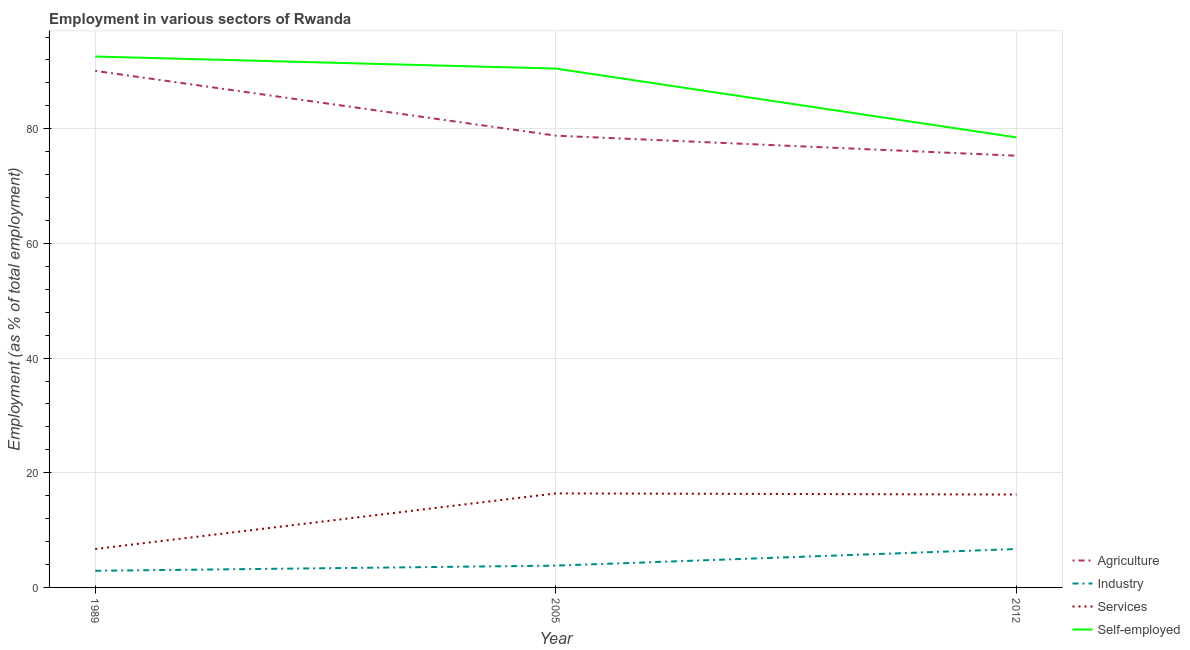Does the line corresponding to percentage of self employed workers intersect with the line corresponding to percentage of workers in agriculture?
Your answer should be compact. No. Is the number of lines equal to the number of legend labels?
Make the answer very short. Yes. What is the percentage of self employed workers in 2012?
Provide a succinct answer. 78.5. Across all years, what is the maximum percentage of self employed workers?
Provide a short and direct response. 92.6. Across all years, what is the minimum percentage of workers in agriculture?
Give a very brief answer. 75.3. In which year was the percentage of workers in agriculture minimum?
Keep it short and to the point. 2012. What is the total percentage of workers in services in the graph?
Offer a very short reply. 39.3. What is the difference between the percentage of self employed workers in 1989 and that in 2005?
Offer a very short reply. 2.1. What is the difference between the percentage of workers in services in 2012 and the percentage of self employed workers in 2005?
Offer a terse response. -74.3. What is the average percentage of workers in agriculture per year?
Give a very brief answer. 81.4. In the year 2005, what is the difference between the percentage of workers in agriculture and percentage of workers in services?
Ensure brevity in your answer.  62.4. In how many years, is the percentage of self employed workers greater than 56 %?
Keep it short and to the point. 3. What is the ratio of the percentage of workers in industry in 2005 to that in 2012?
Keep it short and to the point. 0.57. Is the percentage of workers in agriculture in 1989 less than that in 2005?
Your response must be concise. No. What is the difference between the highest and the second highest percentage of workers in services?
Ensure brevity in your answer.  0.2. What is the difference between the highest and the lowest percentage of workers in industry?
Keep it short and to the point. 3.8. In how many years, is the percentage of workers in services greater than the average percentage of workers in services taken over all years?
Your answer should be compact. 2. Is it the case that in every year, the sum of the percentage of workers in services and percentage of workers in industry is greater than the sum of percentage of self employed workers and percentage of workers in agriculture?
Give a very brief answer. No. Is the percentage of workers in industry strictly less than the percentage of self employed workers over the years?
Provide a short and direct response. Yes. How many lines are there?
Offer a terse response. 4. Are the values on the major ticks of Y-axis written in scientific E-notation?
Make the answer very short. No. Does the graph contain any zero values?
Ensure brevity in your answer.  No. How many legend labels are there?
Offer a very short reply. 4. What is the title of the graph?
Provide a short and direct response. Employment in various sectors of Rwanda. What is the label or title of the X-axis?
Offer a very short reply. Year. What is the label or title of the Y-axis?
Provide a succinct answer. Employment (as % of total employment). What is the Employment (as % of total employment) of Agriculture in 1989?
Offer a very short reply. 90.1. What is the Employment (as % of total employment) of Industry in 1989?
Ensure brevity in your answer.  2.9. What is the Employment (as % of total employment) in Services in 1989?
Keep it short and to the point. 6.7. What is the Employment (as % of total employment) in Self-employed in 1989?
Your response must be concise. 92.6. What is the Employment (as % of total employment) of Agriculture in 2005?
Offer a very short reply. 78.8. What is the Employment (as % of total employment) in Industry in 2005?
Ensure brevity in your answer.  3.8. What is the Employment (as % of total employment) in Services in 2005?
Provide a short and direct response. 16.4. What is the Employment (as % of total employment) in Self-employed in 2005?
Your answer should be very brief. 90.5. What is the Employment (as % of total employment) of Agriculture in 2012?
Your response must be concise. 75.3. What is the Employment (as % of total employment) in Industry in 2012?
Offer a terse response. 6.7. What is the Employment (as % of total employment) in Services in 2012?
Offer a very short reply. 16.2. What is the Employment (as % of total employment) of Self-employed in 2012?
Provide a short and direct response. 78.5. Across all years, what is the maximum Employment (as % of total employment) in Agriculture?
Keep it short and to the point. 90.1. Across all years, what is the maximum Employment (as % of total employment) in Industry?
Your response must be concise. 6.7. Across all years, what is the maximum Employment (as % of total employment) in Services?
Offer a very short reply. 16.4. Across all years, what is the maximum Employment (as % of total employment) in Self-employed?
Make the answer very short. 92.6. Across all years, what is the minimum Employment (as % of total employment) in Agriculture?
Keep it short and to the point. 75.3. Across all years, what is the minimum Employment (as % of total employment) of Industry?
Ensure brevity in your answer.  2.9. Across all years, what is the minimum Employment (as % of total employment) in Services?
Keep it short and to the point. 6.7. Across all years, what is the minimum Employment (as % of total employment) of Self-employed?
Your response must be concise. 78.5. What is the total Employment (as % of total employment) of Agriculture in the graph?
Your response must be concise. 244.2. What is the total Employment (as % of total employment) in Services in the graph?
Your response must be concise. 39.3. What is the total Employment (as % of total employment) in Self-employed in the graph?
Your answer should be compact. 261.6. What is the difference between the Employment (as % of total employment) in Agriculture in 1989 and that in 2005?
Offer a terse response. 11.3. What is the difference between the Employment (as % of total employment) in Industry in 1989 and that in 2005?
Provide a succinct answer. -0.9. What is the difference between the Employment (as % of total employment) in Services in 1989 and that in 2005?
Give a very brief answer. -9.7. What is the difference between the Employment (as % of total employment) of Self-employed in 1989 and that in 2012?
Offer a terse response. 14.1. What is the difference between the Employment (as % of total employment) in Agriculture in 2005 and that in 2012?
Provide a succinct answer. 3.5. What is the difference between the Employment (as % of total employment) of Industry in 2005 and that in 2012?
Your response must be concise. -2.9. What is the difference between the Employment (as % of total employment) of Services in 2005 and that in 2012?
Provide a succinct answer. 0.2. What is the difference between the Employment (as % of total employment) in Agriculture in 1989 and the Employment (as % of total employment) in Industry in 2005?
Give a very brief answer. 86.3. What is the difference between the Employment (as % of total employment) of Agriculture in 1989 and the Employment (as % of total employment) of Services in 2005?
Keep it short and to the point. 73.7. What is the difference between the Employment (as % of total employment) of Agriculture in 1989 and the Employment (as % of total employment) of Self-employed in 2005?
Keep it short and to the point. -0.4. What is the difference between the Employment (as % of total employment) of Industry in 1989 and the Employment (as % of total employment) of Self-employed in 2005?
Provide a short and direct response. -87.6. What is the difference between the Employment (as % of total employment) of Services in 1989 and the Employment (as % of total employment) of Self-employed in 2005?
Provide a succinct answer. -83.8. What is the difference between the Employment (as % of total employment) of Agriculture in 1989 and the Employment (as % of total employment) of Industry in 2012?
Provide a succinct answer. 83.4. What is the difference between the Employment (as % of total employment) in Agriculture in 1989 and the Employment (as % of total employment) in Services in 2012?
Provide a succinct answer. 73.9. What is the difference between the Employment (as % of total employment) in Industry in 1989 and the Employment (as % of total employment) in Services in 2012?
Provide a short and direct response. -13.3. What is the difference between the Employment (as % of total employment) in Industry in 1989 and the Employment (as % of total employment) in Self-employed in 2012?
Keep it short and to the point. -75.6. What is the difference between the Employment (as % of total employment) of Services in 1989 and the Employment (as % of total employment) of Self-employed in 2012?
Your response must be concise. -71.8. What is the difference between the Employment (as % of total employment) of Agriculture in 2005 and the Employment (as % of total employment) of Industry in 2012?
Your answer should be very brief. 72.1. What is the difference between the Employment (as % of total employment) in Agriculture in 2005 and the Employment (as % of total employment) in Services in 2012?
Ensure brevity in your answer.  62.6. What is the difference between the Employment (as % of total employment) of Agriculture in 2005 and the Employment (as % of total employment) of Self-employed in 2012?
Ensure brevity in your answer.  0.3. What is the difference between the Employment (as % of total employment) in Industry in 2005 and the Employment (as % of total employment) in Self-employed in 2012?
Offer a terse response. -74.7. What is the difference between the Employment (as % of total employment) in Services in 2005 and the Employment (as % of total employment) in Self-employed in 2012?
Your answer should be very brief. -62.1. What is the average Employment (as % of total employment) of Agriculture per year?
Ensure brevity in your answer.  81.4. What is the average Employment (as % of total employment) of Industry per year?
Offer a terse response. 4.47. What is the average Employment (as % of total employment) in Self-employed per year?
Keep it short and to the point. 87.2. In the year 1989, what is the difference between the Employment (as % of total employment) in Agriculture and Employment (as % of total employment) in Industry?
Provide a succinct answer. 87.2. In the year 1989, what is the difference between the Employment (as % of total employment) in Agriculture and Employment (as % of total employment) in Services?
Give a very brief answer. 83.4. In the year 1989, what is the difference between the Employment (as % of total employment) of Industry and Employment (as % of total employment) of Self-employed?
Ensure brevity in your answer.  -89.7. In the year 1989, what is the difference between the Employment (as % of total employment) in Services and Employment (as % of total employment) in Self-employed?
Ensure brevity in your answer.  -85.9. In the year 2005, what is the difference between the Employment (as % of total employment) in Agriculture and Employment (as % of total employment) in Services?
Keep it short and to the point. 62.4. In the year 2005, what is the difference between the Employment (as % of total employment) in Industry and Employment (as % of total employment) in Services?
Offer a terse response. -12.6. In the year 2005, what is the difference between the Employment (as % of total employment) in Industry and Employment (as % of total employment) in Self-employed?
Your response must be concise. -86.7. In the year 2005, what is the difference between the Employment (as % of total employment) in Services and Employment (as % of total employment) in Self-employed?
Your answer should be compact. -74.1. In the year 2012, what is the difference between the Employment (as % of total employment) of Agriculture and Employment (as % of total employment) of Industry?
Provide a succinct answer. 68.6. In the year 2012, what is the difference between the Employment (as % of total employment) of Agriculture and Employment (as % of total employment) of Services?
Your answer should be compact. 59.1. In the year 2012, what is the difference between the Employment (as % of total employment) in Agriculture and Employment (as % of total employment) in Self-employed?
Keep it short and to the point. -3.2. In the year 2012, what is the difference between the Employment (as % of total employment) of Industry and Employment (as % of total employment) of Self-employed?
Ensure brevity in your answer.  -71.8. In the year 2012, what is the difference between the Employment (as % of total employment) of Services and Employment (as % of total employment) of Self-employed?
Provide a succinct answer. -62.3. What is the ratio of the Employment (as % of total employment) of Agriculture in 1989 to that in 2005?
Make the answer very short. 1.14. What is the ratio of the Employment (as % of total employment) in Industry in 1989 to that in 2005?
Provide a succinct answer. 0.76. What is the ratio of the Employment (as % of total employment) of Services in 1989 to that in 2005?
Ensure brevity in your answer.  0.41. What is the ratio of the Employment (as % of total employment) in Self-employed in 1989 to that in 2005?
Your answer should be very brief. 1.02. What is the ratio of the Employment (as % of total employment) in Agriculture in 1989 to that in 2012?
Keep it short and to the point. 1.2. What is the ratio of the Employment (as % of total employment) in Industry in 1989 to that in 2012?
Ensure brevity in your answer.  0.43. What is the ratio of the Employment (as % of total employment) in Services in 1989 to that in 2012?
Provide a short and direct response. 0.41. What is the ratio of the Employment (as % of total employment) of Self-employed in 1989 to that in 2012?
Give a very brief answer. 1.18. What is the ratio of the Employment (as % of total employment) of Agriculture in 2005 to that in 2012?
Ensure brevity in your answer.  1.05. What is the ratio of the Employment (as % of total employment) of Industry in 2005 to that in 2012?
Make the answer very short. 0.57. What is the ratio of the Employment (as % of total employment) in Services in 2005 to that in 2012?
Your answer should be very brief. 1.01. What is the ratio of the Employment (as % of total employment) in Self-employed in 2005 to that in 2012?
Your answer should be very brief. 1.15. What is the difference between the highest and the second highest Employment (as % of total employment) in Agriculture?
Your answer should be compact. 11.3. What is the difference between the highest and the second highest Employment (as % of total employment) in Industry?
Offer a terse response. 2.9. What is the difference between the highest and the second highest Employment (as % of total employment) of Services?
Make the answer very short. 0.2. What is the difference between the highest and the second highest Employment (as % of total employment) in Self-employed?
Ensure brevity in your answer.  2.1. What is the difference between the highest and the lowest Employment (as % of total employment) in Agriculture?
Provide a succinct answer. 14.8. What is the difference between the highest and the lowest Employment (as % of total employment) of Industry?
Offer a very short reply. 3.8. What is the difference between the highest and the lowest Employment (as % of total employment) of Services?
Offer a terse response. 9.7. What is the difference between the highest and the lowest Employment (as % of total employment) in Self-employed?
Your answer should be compact. 14.1. 